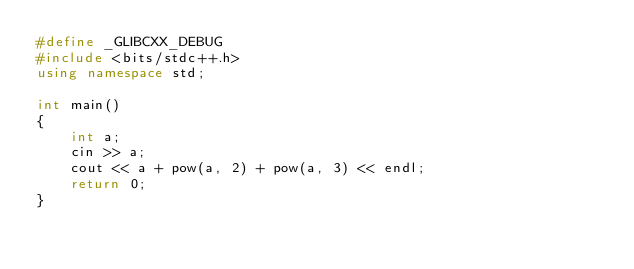Convert code to text. <code><loc_0><loc_0><loc_500><loc_500><_C++_>#define _GLIBCXX_DEBUG
#include <bits/stdc++.h>
using namespace std;

int main()
{
    int a;
    cin >> a;
    cout << a + pow(a, 2) + pow(a, 3) << endl;
    return 0;
}
</code> 